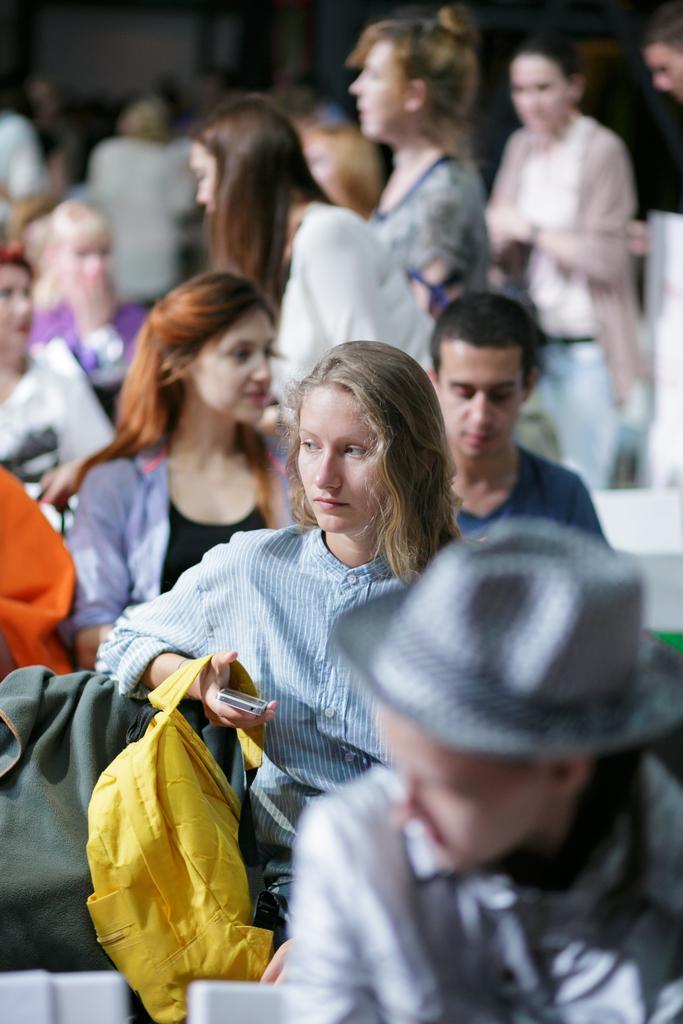Can you describe this image briefly? In the picture there are few people sitting in the front and behind them some other people were standing. In the whole picture only the woman holding yellow bag is highlighted and the remaining were blurred. 